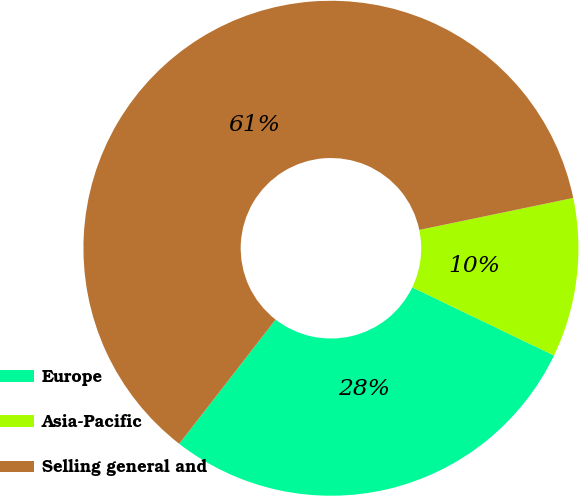<chart> <loc_0><loc_0><loc_500><loc_500><pie_chart><fcel>Europe<fcel>Asia-Pacific<fcel>Selling general and<nl><fcel>28.37%<fcel>10.39%<fcel>61.24%<nl></chart> 